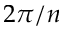<formula> <loc_0><loc_0><loc_500><loc_500>2 \pi / n</formula> 